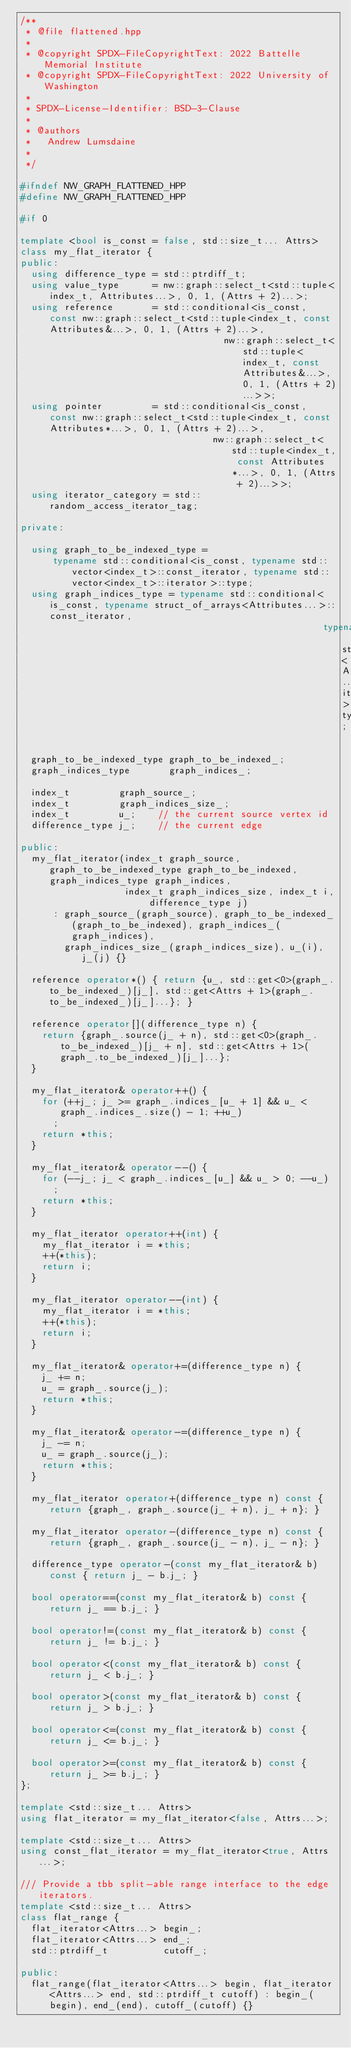Convert code to text. <code><loc_0><loc_0><loc_500><loc_500><_C++_>/**
 * @file flattened.hpp
 *
 * @copyright SPDX-FileCopyrightText: 2022 Battelle Memorial Institute
 * @copyright SPDX-FileCopyrightText: 2022 University of Washington
 *
 * SPDX-License-Identifier: BSD-3-Clause
 *
 * @authors
 *   Andrew Lumsdaine
 *
 */

#ifndef NW_GRAPH_FLATTENED_HPP
#define NW_GRAPH_FLATTENED_HPP

#if 0

template <bool is_const = false, std::size_t... Attrs>
class my_flat_iterator {
public:
  using difference_type = std::ptrdiff_t;
  using value_type      = nw::graph::select_t<std::tuple<index_t, Attributes...>, 0, 1, (Attrs + 2)...>;
  using reference       = std::conditional<is_const, const nw::graph::select_t<std::tuple<index_t, const Attributes&...>, 0, 1, (Attrs + 2)...>,
                                     nw::graph::select_t<std::tuple<index_t, const Attributes&...>, 0, 1, (Attrs + 2)...>>;
  using pointer         = std::conditional<is_const, const nw::graph::select_t<std::tuple<index_t, const Attributes*...>, 0, 1, (Attrs + 2)...>,
                                   nw::graph::select_t<std::tuple<index_t, const Attributes*...>, 0, 1, (Attrs + 2)...>>;
  using iterator_category = std::random_access_iterator_tag;

private:

  using graph_to_be_indexed_type =
      typename std::conditional<is_const, typename std::vector<index_t>::const_iterator, typename std::vector<index_t>::iterator>::type;
  using graph_indices_type = typename std::conditional<is_const, typename struct_of_arrays<Attributes...>::const_iterator,
                                                       typename struct_of_arrays<Attributes...>::iterator>::type;

  graph_to_be_indexed_type graph_to_be_indexed_;
  graph_indices_type       graph_indices_;

  index_t         graph_source_;
  index_t         graph_indices_size_;
  index_t         u_;    // the current source vertex id
  difference_type j_;    // the current edge

public:
  my_flat_iterator(index_t graph_source, graph_to_be_indexed_type graph_to_be_indexed, graph_indices_type graph_indices,
                   index_t graph_indices_size, index_t i, difference_type j)
      : graph_source_(graph_source), graph_to_be_indexed_(graph_to_be_indexed), graph_indices_(graph_indices),
        graph_indices_size_(graph_indices_size), u_(i), j_(j) {}

  reference operator*() { return {u_, std::get<0>(graph_.to_be_indexed_)[j_], std::get<Attrs + 1>(graph_.to_be_indexed_)[j_]...}; }

  reference operator[](difference_type n) {
    return {graph_.source(j_ + n), std::get<0>(graph_.to_be_indexed_)[j_ + n], std::get<Attrs + 1>(graph_.to_be_indexed_)[j_]...};
  }

  my_flat_iterator& operator++() {
    for (++j_; j_ >= graph_.indices_[u_ + 1] && u_ < graph_.indices_.size() - 1; ++u_)
      ;
    return *this;
  }

  my_flat_iterator& operator--() {
    for (--j_; j_ < graph_.indices_[u_] && u_ > 0; --u_)
      ;
    return *this;
  }

  my_flat_iterator operator++(int) {
    my_flat_iterator i = *this;
    ++(*this);
    return i;
  }

  my_flat_iterator operator--(int) {
    my_flat_iterator i = *this;
    ++(*this);
    return i;
  }

  my_flat_iterator& operator+=(difference_type n) {
    j_ += n;
    u_ = graph_.source(j_);
    return *this;
  }

  my_flat_iterator& operator-=(difference_type n) {
    j_ -= n;
    u_ = graph_.source(j_);
    return *this;
  }

  my_flat_iterator operator+(difference_type n) const { return {graph_, graph_.source(j_ + n), j_ + n}; }

  my_flat_iterator operator-(difference_type n) const { return {graph_, graph_.source(j_ - n), j_ - n}; }

  difference_type operator-(const my_flat_iterator& b) const { return j_ - b.j_; }

  bool operator==(const my_flat_iterator& b) const { return j_ == b.j_; }

  bool operator!=(const my_flat_iterator& b) const { return j_ != b.j_; }

  bool operator<(const my_flat_iterator& b) const { return j_ < b.j_; }

  bool operator>(const my_flat_iterator& b) const { return j_ > b.j_; }

  bool operator<=(const my_flat_iterator& b) const { return j_ <= b.j_; }

  bool operator>=(const my_flat_iterator& b) const { return j_ >= b.j_; }
};

template <std::size_t... Attrs>
using flat_iterator = my_flat_iterator<false, Attrs...>;

template <std::size_t... Attrs>
using const_flat_iterator = my_flat_iterator<true, Attrs...>;

/// Provide a tbb split-able range interface to the edge iterators.
template <std::size_t... Attrs>
class flat_range {
  flat_iterator<Attrs...> begin_;
  flat_iterator<Attrs...> end_;
  std::ptrdiff_t          cutoff_;

public:
  flat_range(flat_iterator<Attrs...> begin, flat_iterator<Attrs...> end, std::ptrdiff_t cutoff) : begin_(begin), end_(end), cutoff_(cutoff) {}
</code> 